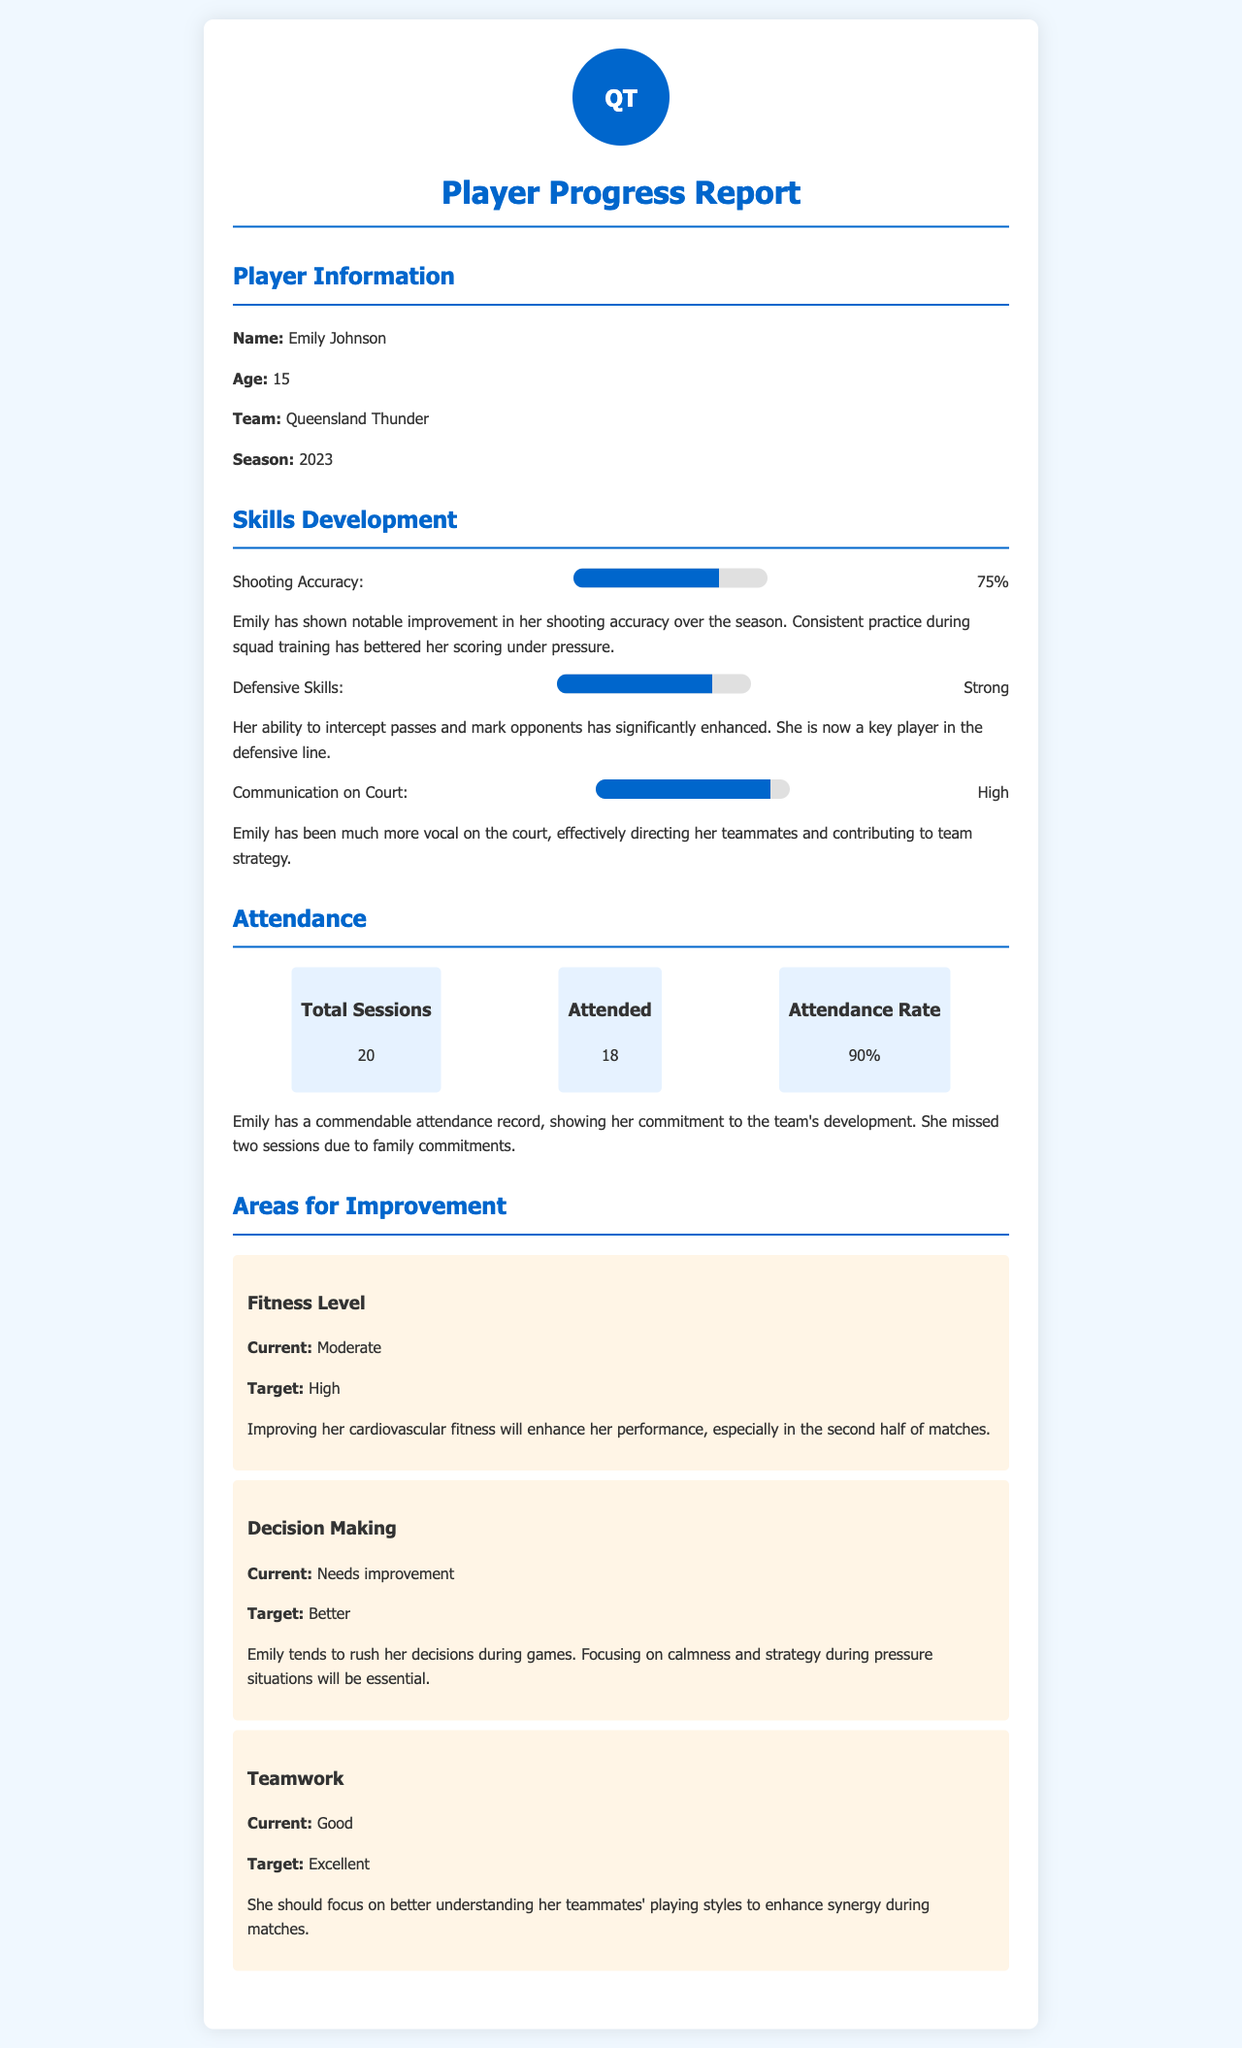What is the name of the player? The player's name is mentioned at the beginning of the report in the player information section.
Answer: Emily Johnson What age is Emily Johnson? The age of Emily Johnson is provided in the player information section.
Answer: 15 What is Emily's attendance rate? The attendance rate is specified in the attendance section of the report.
Answer: 90% How many total sessions were there? The total sessions are detailed in the attendance section of the report.
Answer: 20 What is the current fitness level of Emily? The current fitness level is listed under the areas for improvement section.
Answer: Moderate What target fitness level does Emily aim for? The target fitness level is included in the areas for improvement section.
Answer: High What skill has Emily shown the most improvement in? The skills development section highlights the areas where Emily has improved significantly.
Answer: Shooting Accuracy What does Emily need to improve her decision-making? The reasoning for improvement is laid out in the areas for improvement section.
Answer: Calmness What is Emily's current teamwork level? The current teamwork level is mentioned in the areas for improvement section.
Answer: Good How many sessions did Emily miss? The total number of missed sessions is provided in the attendance section of the report.
Answer: 2 